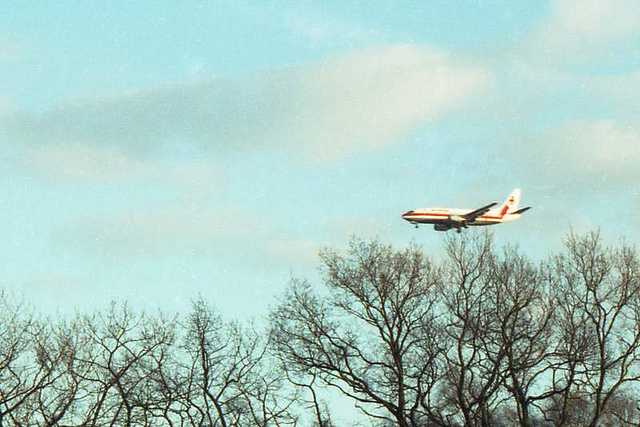<image>What airline is this plane from? I don't know what airline this plane is from. It can be from British air, American airlines, Panama, United, or Delta. What airline is this plane from? I don't know what airline is this plane from. It can be from 'british air', 'american', 'american airlines', 'panama', 'united', 'commercial', 'delta' or 'united'. 